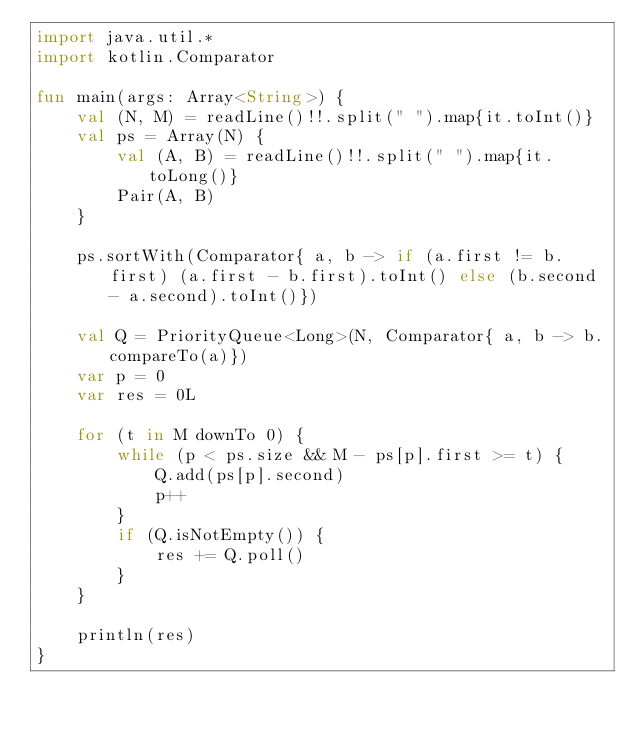<code> <loc_0><loc_0><loc_500><loc_500><_Kotlin_>import java.util.*
import kotlin.Comparator

fun main(args: Array<String>) {
    val (N, M) = readLine()!!.split(" ").map{it.toInt()}
    val ps = Array(N) {
        val (A, B) = readLine()!!.split(" ").map{it.toLong()}
        Pair(A, B)
    }

    ps.sortWith(Comparator{ a, b -> if (a.first != b.first) (a.first - b.first).toInt() else (b.second - a.second).toInt()})

    val Q = PriorityQueue<Long>(N, Comparator{ a, b -> b.compareTo(a)})
    var p = 0
    var res = 0L

    for (t in M downTo 0) {
        while (p < ps.size && M - ps[p].first >= t) {
            Q.add(ps[p].second)
            p++
        }
        if (Q.isNotEmpty()) {
            res += Q.poll()
        }
    }

    println(res)
}
</code> 